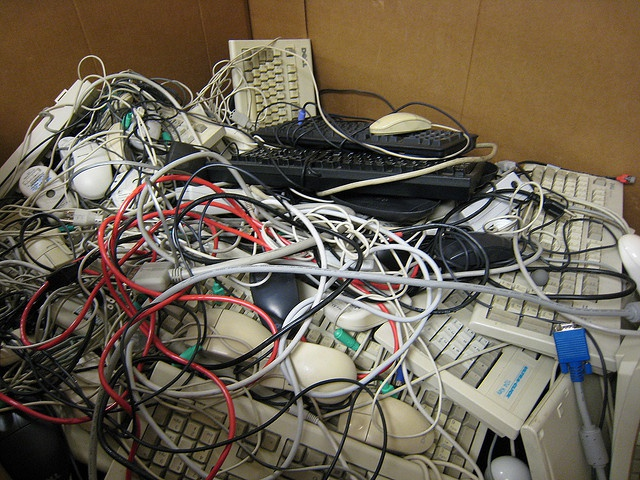Describe the objects in this image and their specific colors. I can see keyboard in maroon, gray, darkgray, and black tones, keyboard in maroon, black, gray, darkgray, and lightgray tones, keyboard in maroon, darkgray, beige, lightgray, and gray tones, keyboard in maroon, black, darkgray, gray, and lightgray tones, and keyboard in maroon, black, gray, and beige tones in this image. 